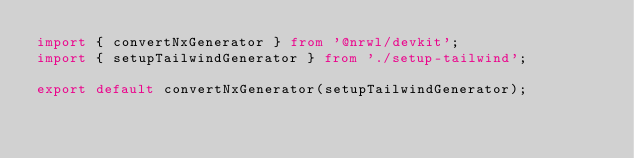<code> <loc_0><loc_0><loc_500><loc_500><_TypeScript_>import { convertNxGenerator } from '@nrwl/devkit';
import { setupTailwindGenerator } from './setup-tailwind';

export default convertNxGenerator(setupTailwindGenerator);
</code> 